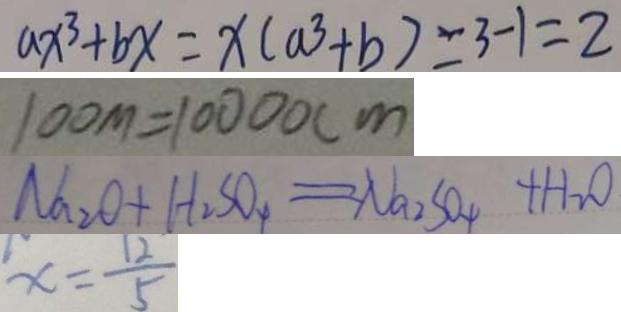<formula> <loc_0><loc_0><loc_500><loc_500>a x ^ { 3 } + b x = x ( a ^ { 3 } + b ) = 3 - 1 = 2 
 1 0 0 m = 1 0 0 0 0 c m 
 N a _ { 2 } O + H _ { 2 } S O _ { 4 } = N a _ { 2 } S O _ { 4 } + H _ { 2 } O 
 x = \frac { 1 2 } { 5 }</formula> 